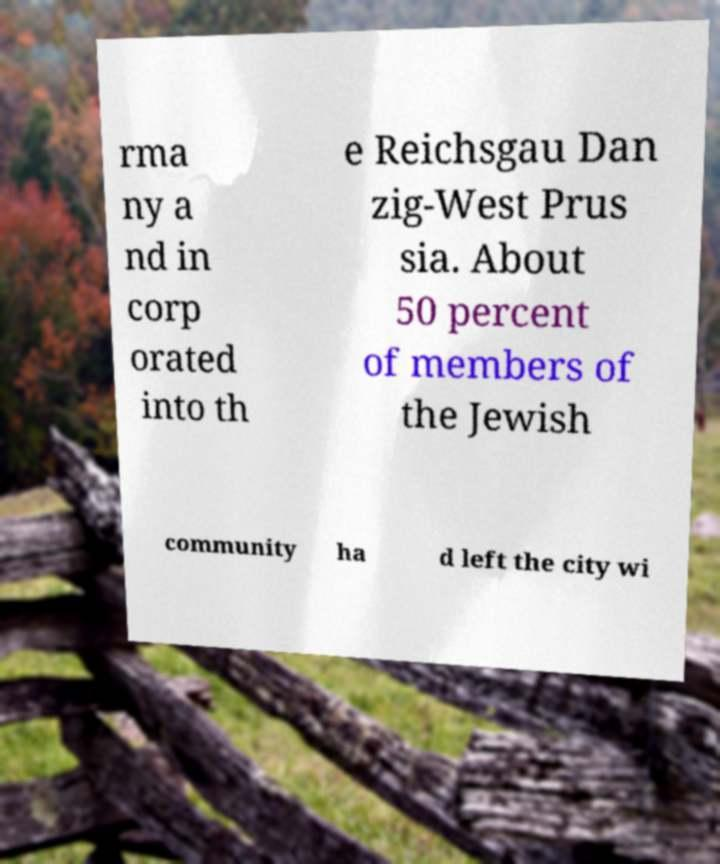What messages or text are displayed in this image? I need them in a readable, typed format. rma ny a nd in corp orated into th e Reichsgau Dan zig-West Prus sia. About 50 percent of members of the Jewish community ha d left the city wi 